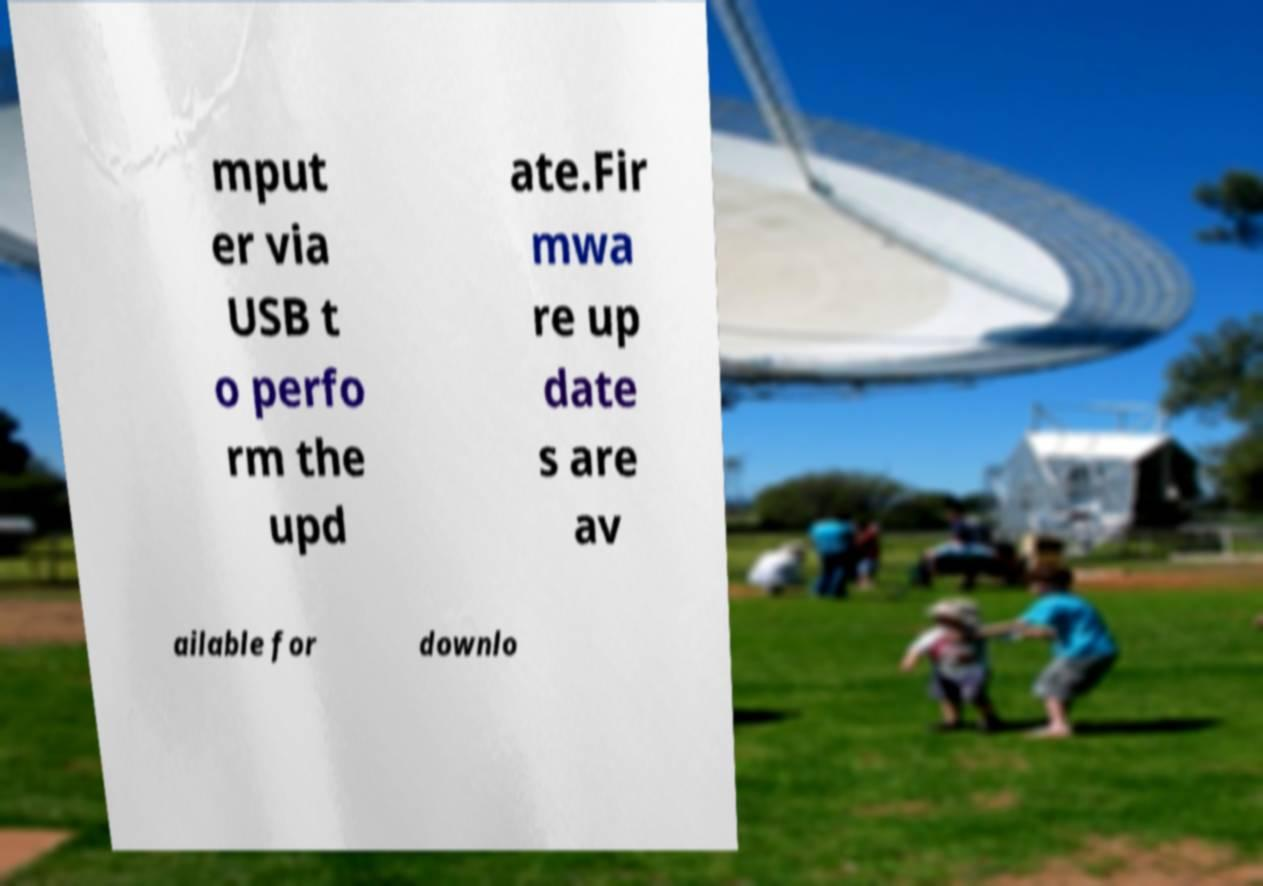Could you assist in decoding the text presented in this image and type it out clearly? mput er via USB t o perfo rm the upd ate.Fir mwa re up date s are av ailable for downlo 